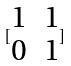Convert formula to latex. <formula><loc_0><loc_0><loc_500><loc_500>[ \begin{matrix} 1 & 1 \\ 0 & 1 \end{matrix} ]</formula> 